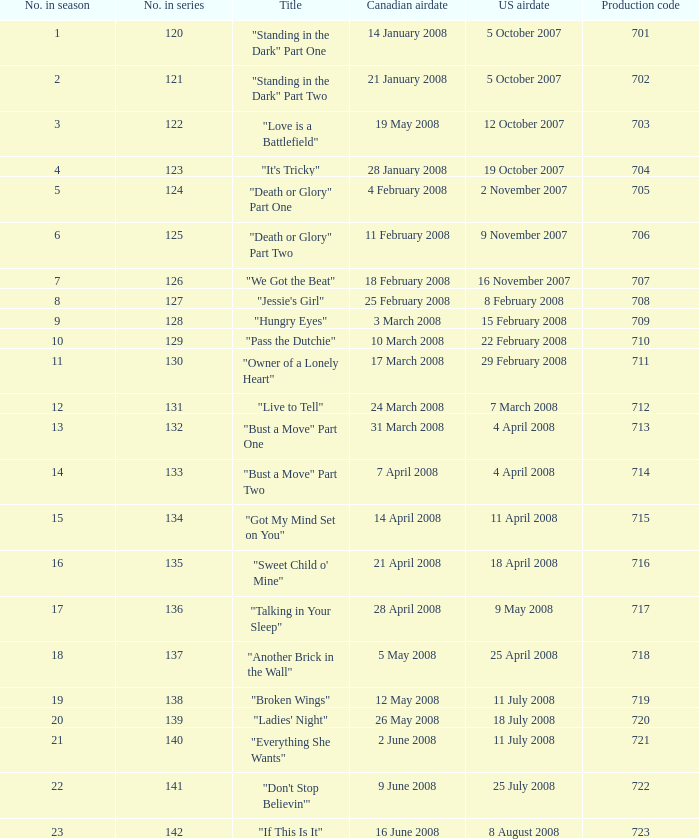Would you mind parsing the complete table? {'header': ['No. in season', 'No. in series', 'Title', 'Canadian airdate', 'US airdate', 'Production code'], 'rows': [['1', '120', '"Standing in the Dark" Part One', '14 January 2008', '5 October 2007', '701'], ['2', '121', '"Standing in the Dark" Part Two', '21 January 2008', '5 October 2007', '702'], ['3', '122', '"Love is a Battlefield"', '19 May 2008', '12 October 2007', '703'], ['4', '123', '"It\'s Tricky"', '28 January 2008', '19 October 2007', '704'], ['5', '124', '"Death or Glory" Part One', '4 February 2008', '2 November 2007', '705'], ['6', '125', '"Death or Glory" Part Two', '11 February 2008', '9 November 2007', '706'], ['7', '126', '"We Got the Beat"', '18 February 2008', '16 November 2007', '707'], ['8', '127', '"Jessie\'s Girl"', '25 February 2008', '8 February 2008', '708'], ['9', '128', '"Hungry Eyes"', '3 March 2008', '15 February 2008', '709'], ['10', '129', '"Pass the Dutchie"', '10 March 2008', '22 February 2008', '710'], ['11', '130', '"Owner of a Lonely Heart"', '17 March 2008', '29 February 2008', '711'], ['12', '131', '"Live to Tell"', '24 March 2008', '7 March 2008', '712'], ['13', '132', '"Bust a Move" Part One', '31 March 2008', '4 April 2008', '713'], ['14', '133', '"Bust a Move" Part Two', '7 April 2008', '4 April 2008', '714'], ['15', '134', '"Got My Mind Set on You"', '14 April 2008', '11 April 2008', '715'], ['16', '135', '"Sweet Child o\' Mine"', '21 April 2008', '18 April 2008', '716'], ['17', '136', '"Talking in Your Sleep"', '28 April 2008', '9 May 2008', '717'], ['18', '137', '"Another Brick in the Wall"', '5 May 2008', '25 April 2008', '718'], ['19', '138', '"Broken Wings"', '12 May 2008', '11 July 2008', '719'], ['20', '139', '"Ladies\' Night"', '26 May 2008', '18 July 2008', '720'], ['21', '140', '"Everything She Wants"', '2 June 2008', '11 July 2008', '721'], ['22', '141', '"Don\'t Stop Believin\'"', '9 June 2008', '25 July 2008', '722'], ['23', '142', '"If This Is It"', '16 June 2008', '8 August 2008', '723']]} What were the names of the episode(s) that aired in the u.s. on april 4, 2008? "Bust a Move" Part One, "Bust a Move" Part Two. 